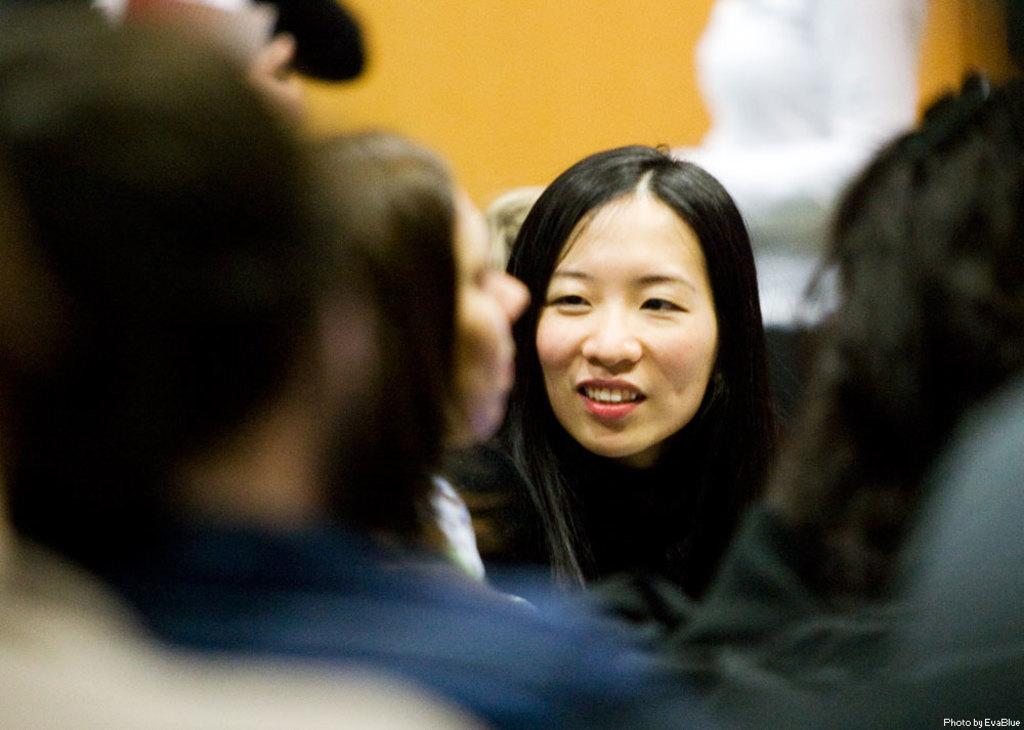Please provide a concise description of this image. In the picture we can see some group of people from it, we can see a woman's face with loose hair and smile and behind her we can see a wall and a part of a white sculpture near it. 